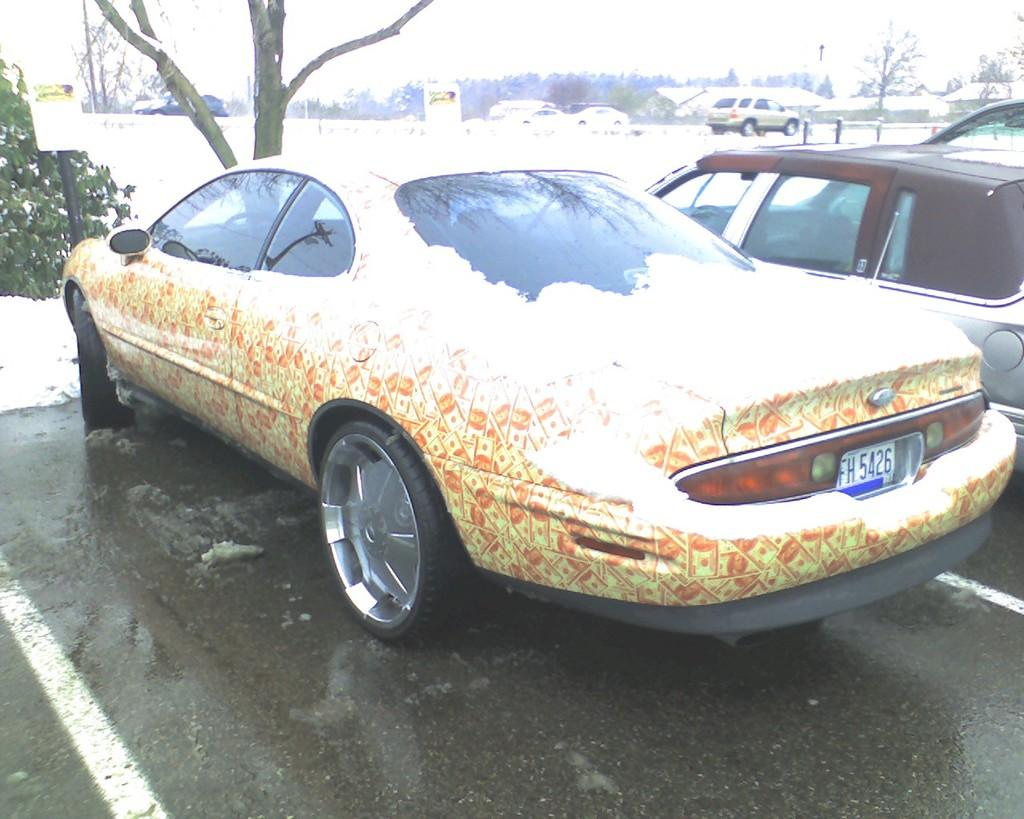What can be found in the parking space in the image? There are vehicles in the parking space in the image. What is the weather condition in the image? There is snow visible in the image. What type of natural elements can be seen in the image? There are trees in the image. What is the name of the person who created the snow in the image? There is no person responsible for creating the snow in the image; it is a natural weather condition. 